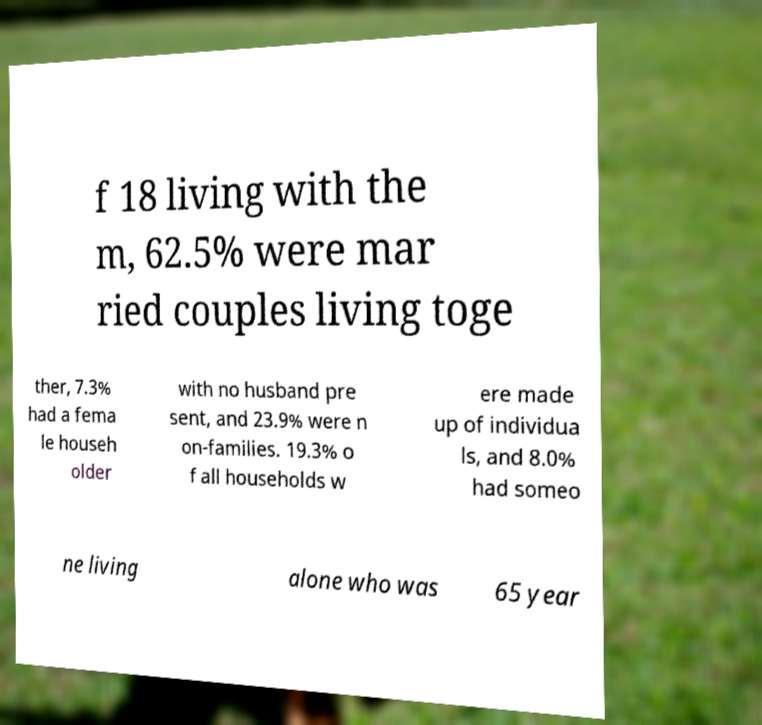What messages or text are displayed in this image? I need them in a readable, typed format. f 18 living with the m, 62.5% were mar ried couples living toge ther, 7.3% had a fema le househ older with no husband pre sent, and 23.9% were n on-families. 19.3% o f all households w ere made up of individua ls, and 8.0% had someo ne living alone who was 65 year 